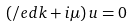<formula> <loc_0><loc_0><loc_500><loc_500>( \slash e d { k } + i \mu ) \, u = 0</formula> 